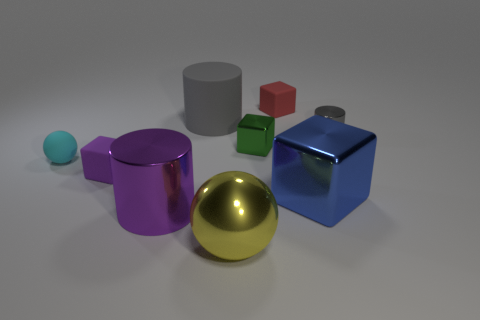There is a metallic cylinder that is the same size as the green block; what is its color?
Your answer should be compact. Gray. Do the ball that is behind the blue thing and the purple cylinder have the same material?
Make the answer very short. No. There is a small matte block that is on the left side of the cylinder that is in front of the small purple cube; is there a block that is in front of it?
Ensure brevity in your answer.  Yes. Do the tiny shiny thing to the left of the big blue metal thing and the red rubber object have the same shape?
Keep it short and to the point. Yes. What is the shape of the large metal object behind the shiny cylinder in front of the green cube?
Offer a terse response. Cube. How big is the rubber block on the right side of the big purple shiny object that is right of the rubber block that is to the left of the yellow ball?
Offer a very short reply. Small. What color is the small thing that is the same shape as the big yellow metal thing?
Your response must be concise. Cyan. Is the size of the gray shiny object the same as the purple matte cube?
Give a very brief answer. Yes. What is the material of the ball in front of the purple cube?
Your answer should be compact. Metal. What number of other objects are there of the same shape as the large yellow metal object?
Keep it short and to the point. 1. 